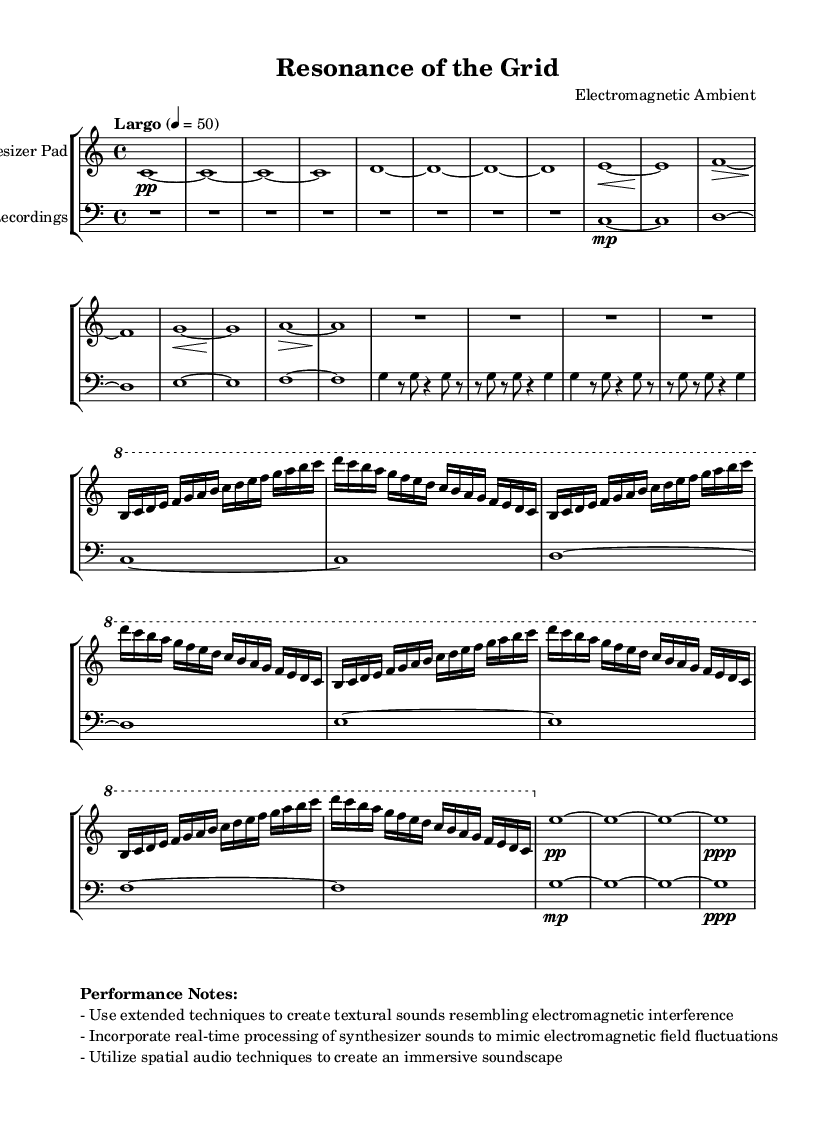What is the time signature of this music? The time signature is indicated in the global settings of the sheet music, which shows a 4/4 time signature for the entire composition.
Answer: 4/4 What is the tempo marking for this piece? The tempo marking specified in the global settings is "Largo," with a metronome marking of 50 beats per minute.
Answer: Largo, 50 How many measures are in the Main Theme? The Main Theme section consists of 8 measures, as indicated in the music code and visually represented in the sheet music.
Answer: 8 measures What dynamic marking is present at the end of the Outro section? The Outro section features a dynamic marking of "ppp," indicating a very soft sound. This is shown clearly at the end of the measure.
Answer: ppp What instrument is indicated for the processed field recordings? In the staff notation, the processed field recordings are labeled as "Processed Field Recordings," specifying the instrument for that part.
Answer: Processed Field Recordings What extended techniques are suggested in the performance notes? The performance notes suggest using extended techniques that create textural sounds resembling electromagnetic interference, which may require unconventional playing methods.
Answer: Extended techniques How many octaves does the synthesizer pad part span? The synthesizer pad part spans one octave, from C to B in the notation, as it is displayed between the registers used in this piece.
Answer: One octave 